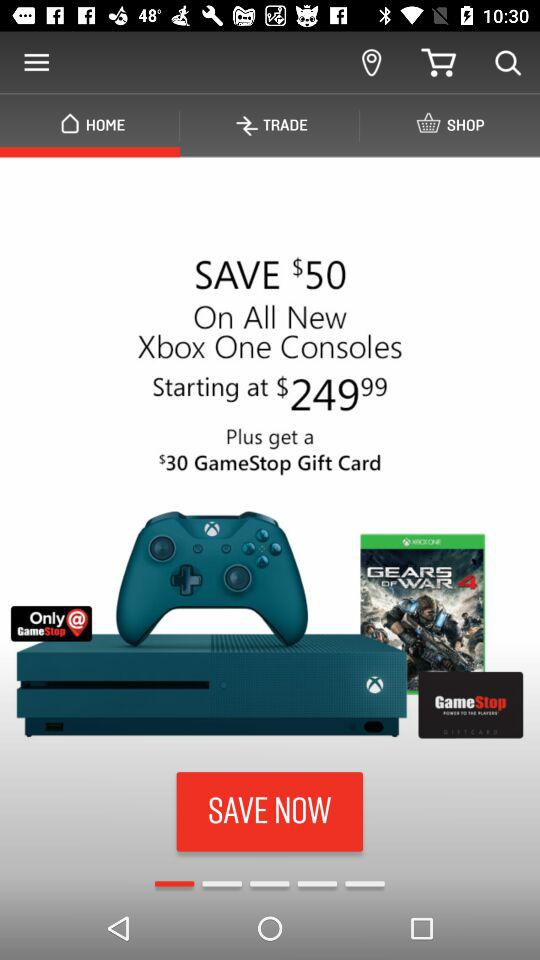How much money can be saved on the "Xbox One"? On the "Xbox One", $50 can be saved. 